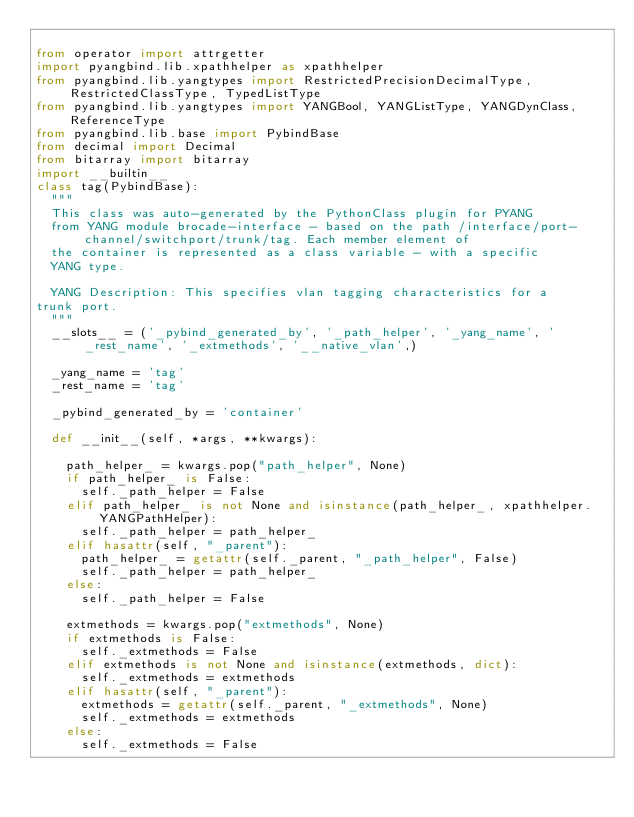Convert code to text. <code><loc_0><loc_0><loc_500><loc_500><_Python_>
from operator import attrgetter
import pyangbind.lib.xpathhelper as xpathhelper
from pyangbind.lib.yangtypes import RestrictedPrecisionDecimalType, RestrictedClassType, TypedListType
from pyangbind.lib.yangtypes import YANGBool, YANGListType, YANGDynClass, ReferenceType
from pyangbind.lib.base import PybindBase
from decimal import Decimal
from bitarray import bitarray
import __builtin__
class tag(PybindBase):
  """
  This class was auto-generated by the PythonClass plugin for PYANG
  from YANG module brocade-interface - based on the path /interface/port-channel/switchport/trunk/tag. Each member element of
  the container is represented as a class variable - with a specific
  YANG type.

  YANG Description: This specifies vlan tagging characteristics for a 
trunk port.
  """
  __slots__ = ('_pybind_generated_by', '_path_helper', '_yang_name', '_rest_name', '_extmethods', '__native_vlan',)

  _yang_name = 'tag'
  _rest_name = 'tag'

  _pybind_generated_by = 'container'

  def __init__(self, *args, **kwargs):

    path_helper_ = kwargs.pop("path_helper", None)
    if path_helper_ is False:
      self._path_helper = False
    elif path_helper_ is not None and isinstance(path_helper_, xpathhelper.YANGPathHelper):
      self._path_helper = path_helper_
    elif hasattr(self, "_parent"):
      path_helper_ = getattr(self._parent, "_path_helper", False)
      self._path_helper = path_helper_
    else:
      self._path_helper = False

    extmethods = kwargs.pop("extmethods", None)
    if extmethods is False:
      self._extmethods = False
    elif extmethods is not None and isinstance(extmethods, dict):
      self._extmethods = extmethods
    elif hasattr(self, "_parent"):
      extmethods = getattr(self._parent, "_extmethods", None)
      self._extmethods = extmethods
    else:
      self._extmethods = False</code> 